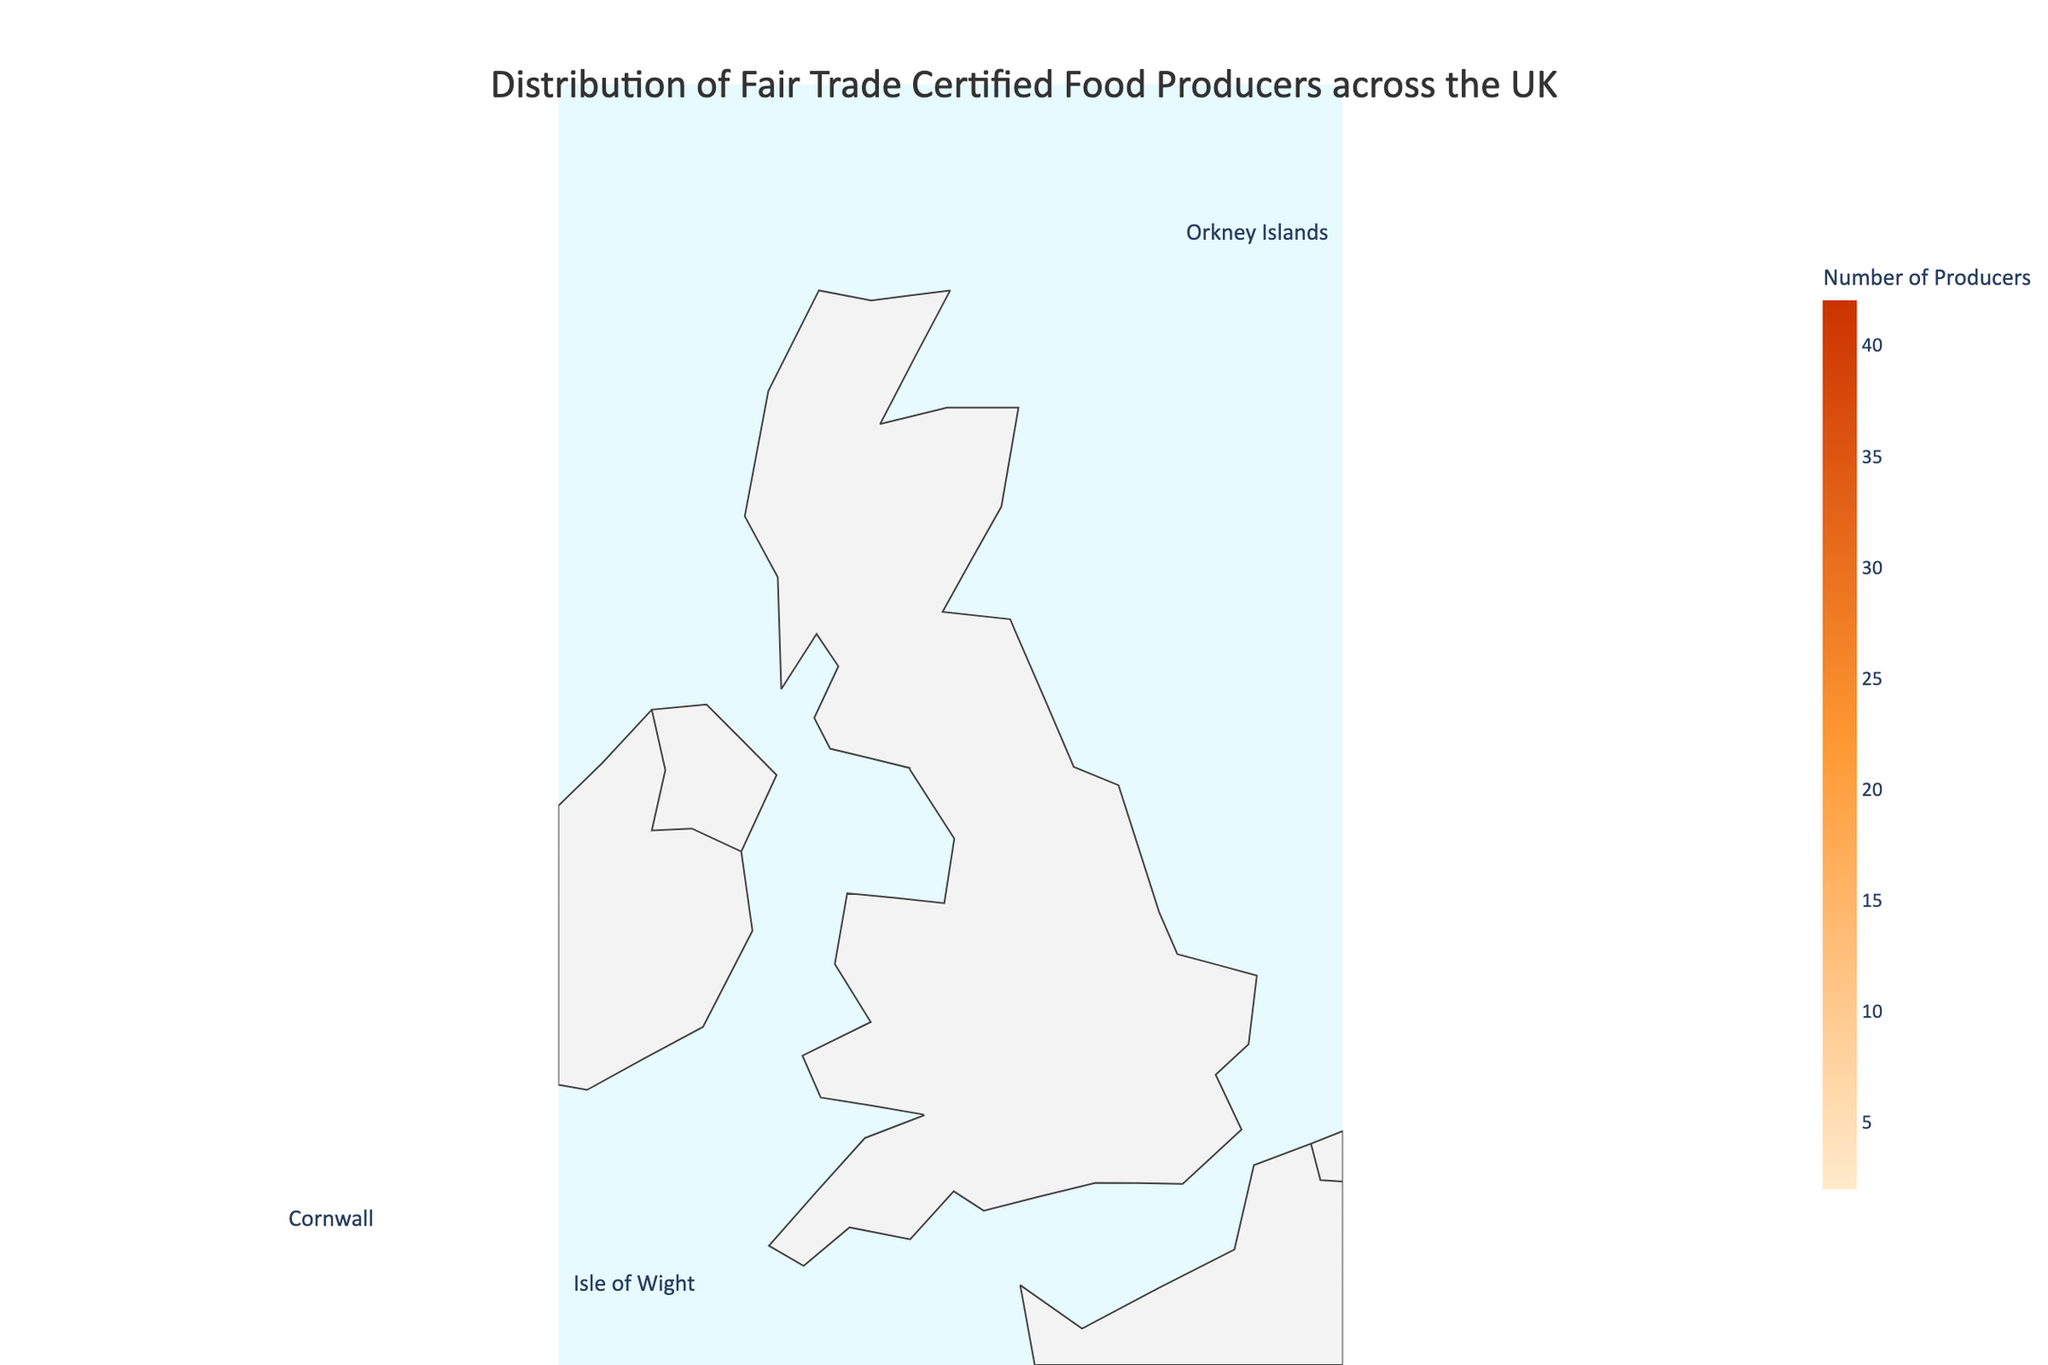Which region has the highest number of Fair Trade certified food producers? The figure indicates that Greater London has the darkest shade, representing the highest number of producers. By reading the accompanying legend, we can confirm this.
Answer: Greater London Which regions have fewer than 10 Fair Trade certified food producers? The regions Cornwall, Isle of Wight, and Orkney Islands are annotated separately and have lighter shades. From the data, these regions all have fewer than 10 producers - Cornwall (9), Isle of Wight (3), Orkney Islands (2).
Answer: Cornwall, Isle of Wight, Orkney Islands How many Fair Trade certified food producers are there in South West England compared to Scotland? From the color scale and numerical values present in the figure, South West England has 35 producers while Scotland has 31 producers.
Answer: South West England: 35, Scotland: 31 What is the total number of Fair Trade certified food producers in Greater London, East of England, and North West England combined? Adding the number of producers in these regions: Greater London (42) + East of England (19) + North West England (26) = 87
Answer: 87 Are there more Fair Trade certified food producers in Wales or Northern Ireland? By referencing the figure, Wales is marked with 18 producers and Northern Ireland with 12 producers. Clearly, Wales has more producers.
Answer: Wales What is the average number of Fair Trade certified food producers in the South East and North East regions of England? By summing the producers in South East England (28) and North East England (14) and dividing by the number of regions (2), we get (28 + 14) / 2 = 21.
Answer: 21 Which color represents regions with the lowest number of Fair Trade certified food producers? The custom color scale indicates that the lightest yellow shade represents the lowest number of producers.
Answer: Light yellow Is the number of Fair Trade certified food producers in the East Midlands greater than in Wales? According to the figure, the East Midlands has 17 producers, while Wales has 18. Thus, Wales has more producers than the East Midlands.
Answer: No What is the median number of Fair Trade certified food producers among all regions shown? First, we list the number of producers: 42, 28, 35, 19, 23, 17, 21, 26, 14, 31, 18, 12, 9, 3, 2. Arranging ascending: 2, 3, 9, 12, 14, 17, 18, 19, 21, 23, 26, 28, 31, 35, 42. The median value is thus 19 (the middle value).
Answer: 19 